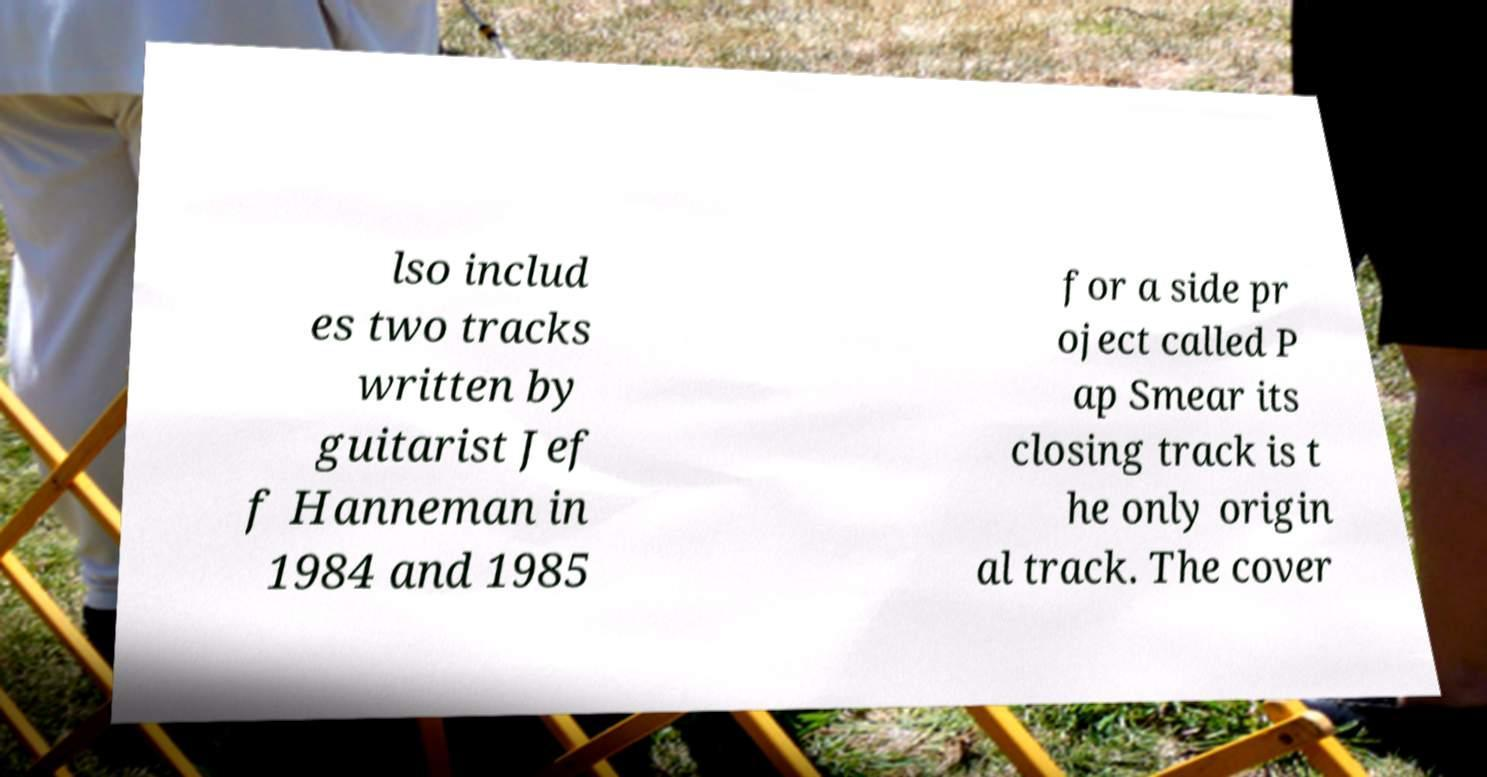Please identify and transcribe the text found in this image. lso includ es two tracks written by guitarist Jef f Hanneman in 1984 and 1985 for a side pr oject called P ap Smear its closing track is t he only origin al track. The cover 